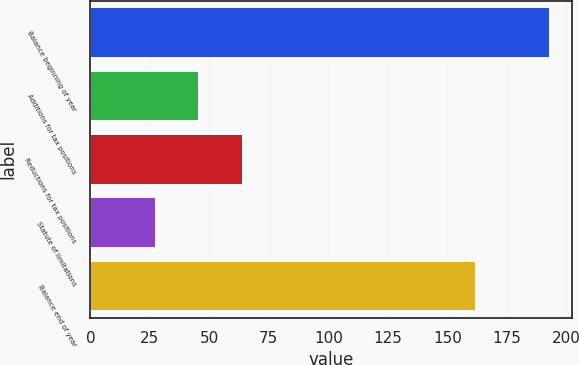Convert chart to OTSL. <chart><loc_0><loc_0><loc_500><loc_500><bar_chart><fcel>Balance beginning of year<fcel>Additions for tax positions<fcel>Reductions for tax positions<fcel>Statute of limitations<fcel>Balance end of year<nl><fcel>193<fcel>45.8<fcel>64.2<fcel>27.4<fcel>162<nl></chart> 